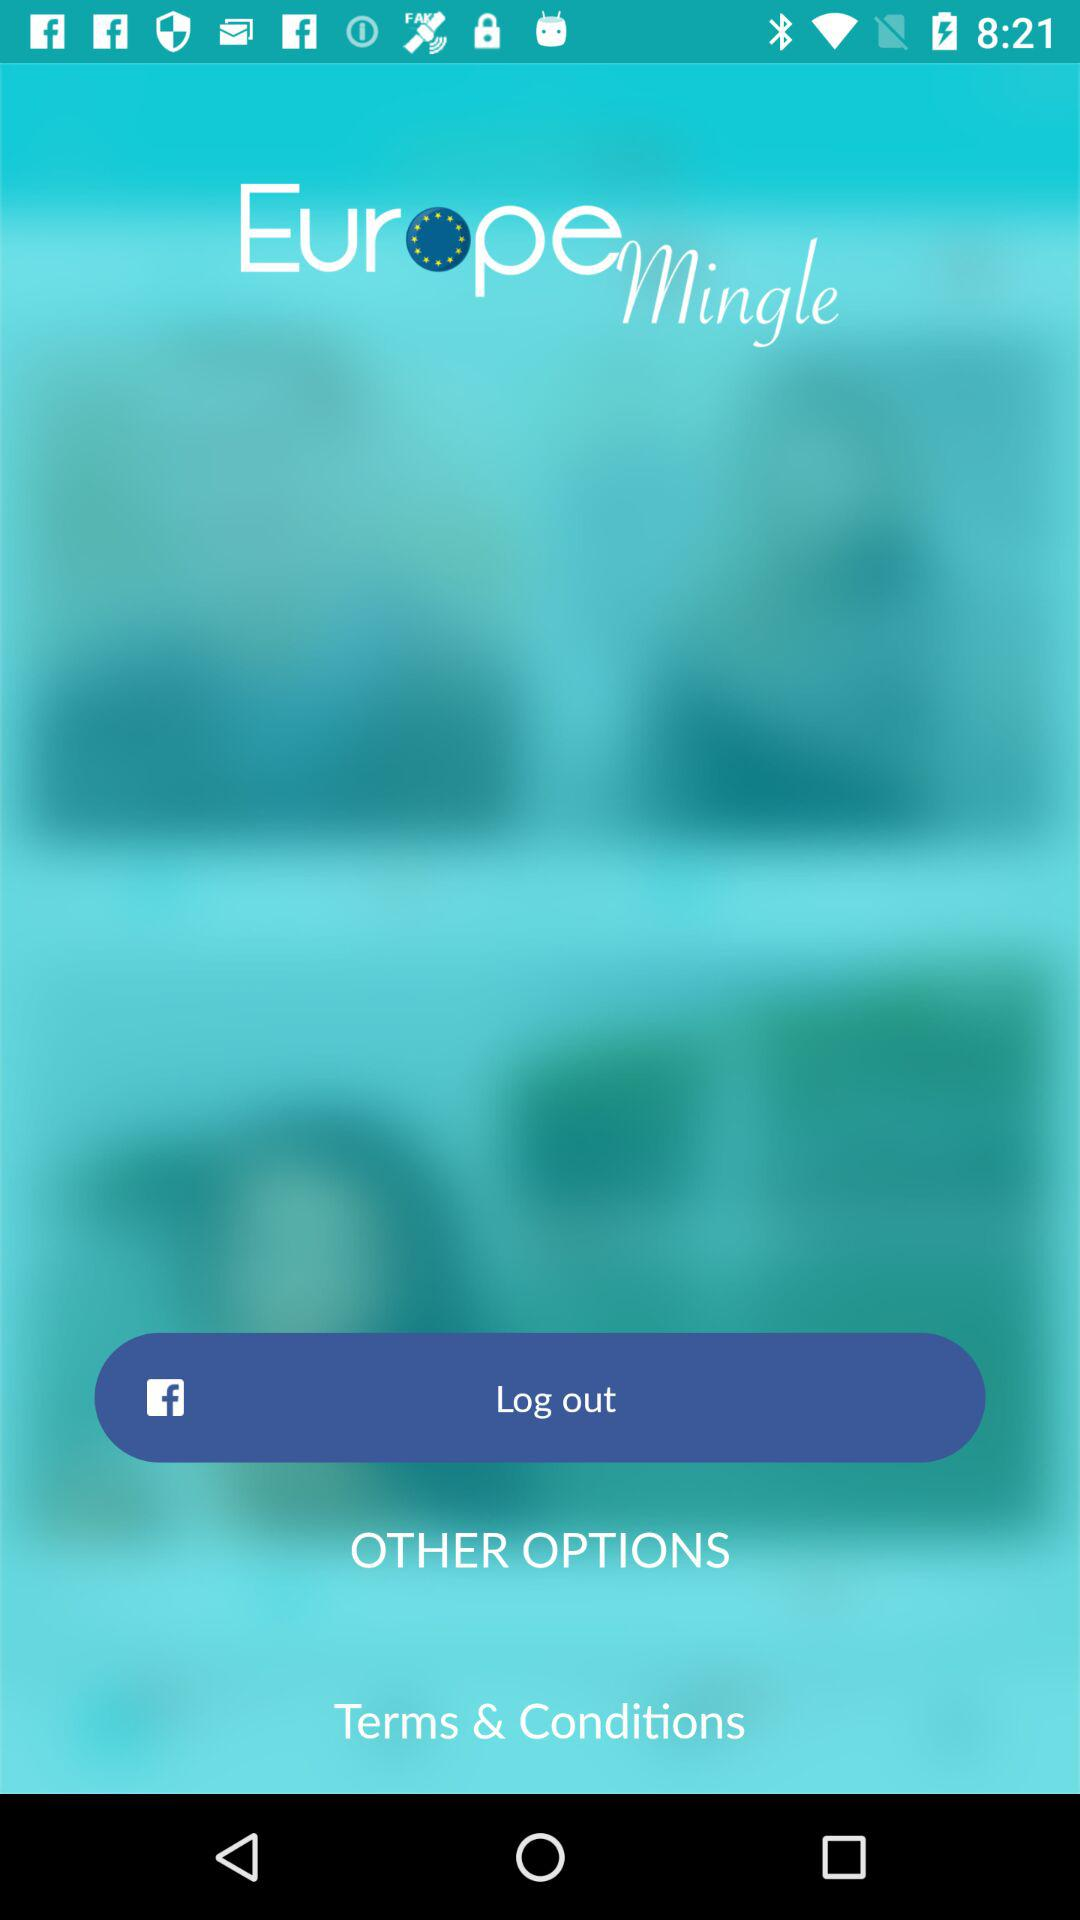What is the name of the application? The name of the application is "Europe Mingle". 